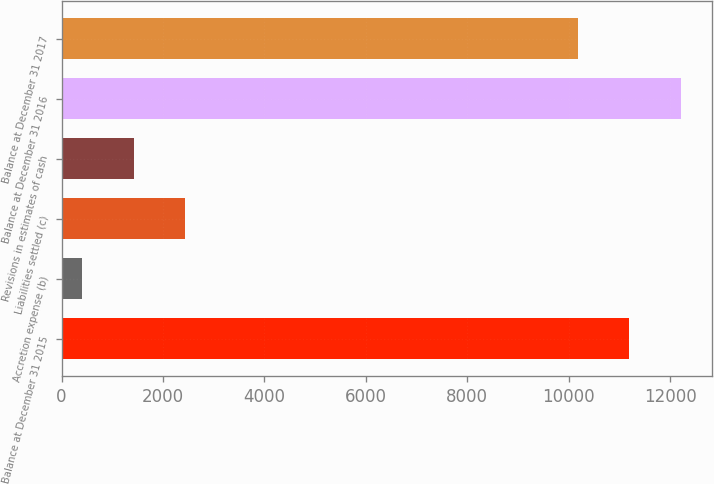<chart> <loc_0><loc_0><loc_500><loc_500><bar_chart><fcel>Balance at December 31 2015<fcel>Accretion expense (b)<fcel>Liabilities settled (c)<fcel>Revisions in estimates of cash<fcel>Balance at December 31 2016<fcel>Balance at December 31 2017<nl><fcel>11196.1<fcel>400<fcel>2442.2<fcel>1421.1<fcel>12217.2<fcel>10175<nl></chart> 